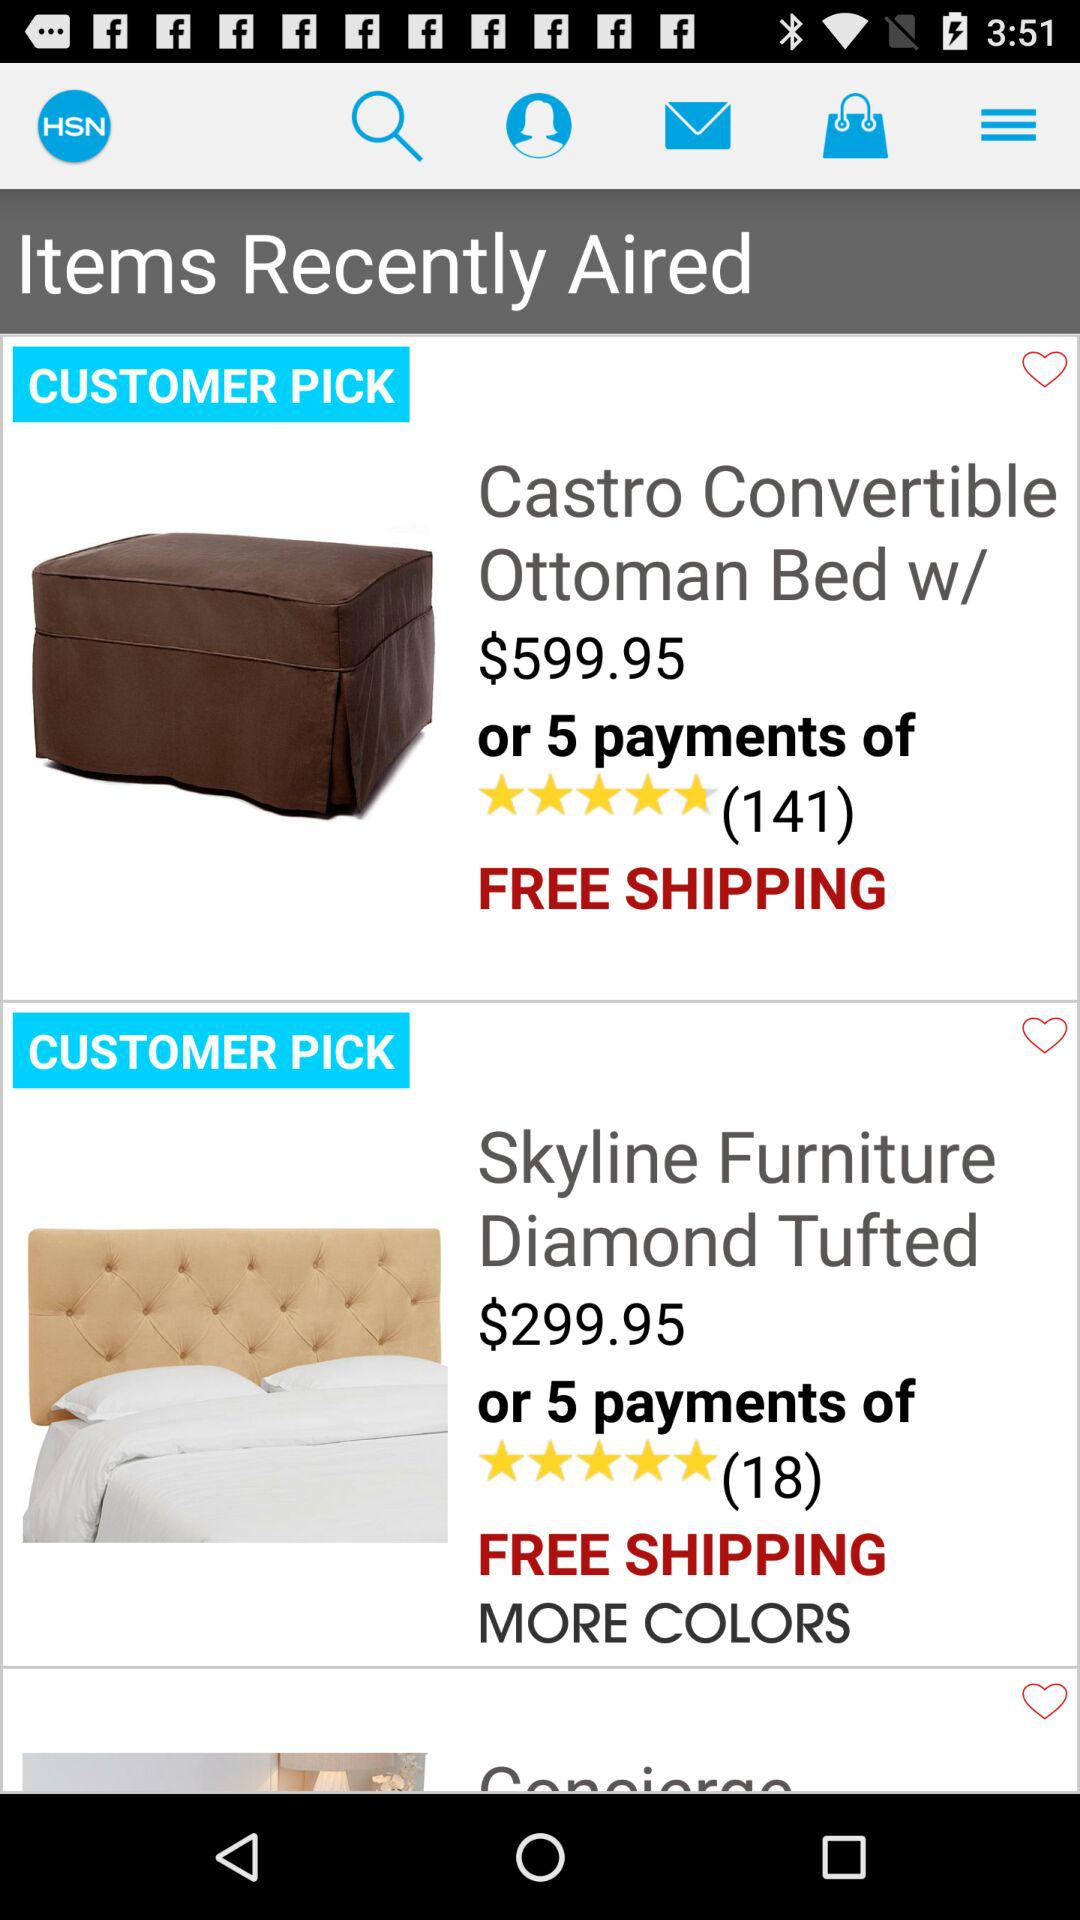What is the price of "Skyline Furniture Diamond Tufted"? The price of "Skyline Furniture Diamond Tufted" is $299.95. 